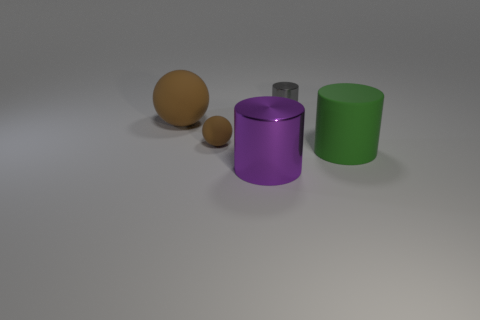Are there more shiny cylinders than small rubber spheres?
Ensure brevity in your answer.  Yes. Do the cylinder that is behind the large rubber cylinder and the cylinder that is to the left of the small gray object have the same size?
Your answer should be compact. No. How many rubber objects are on the right side of the large purple shiny object and left of the small cylinder?
Keep it short and to the point. 0. What color is the other shiny thing that is the same shape as the big purple shiny object?
Provide a succinct answer. Gray. Are there fewer shiny objects than gray objects?
Offer a very short reply. No. There is a gray cylinder; is it the same size as the metal cylinder that is in front of the big brown matte ball?
Your answer should be compact. No. What color is the large object that is in front of the big object that is on the right side of the tiny cylinder?
Your response must be concise. Purple. What number of objects are either objects that are on the right side of the small brown rubber object or metallic things that are in front of the tiny metallic object?
Provide a succinct answer. 3. Do the green rubber cylinder and the purple cylinder have the same size?
Offer a very short reply. Yes. There is a metallic object in front of the large brown ball; is it the same shape as the large thing right of the purple shiny thing?
Ensure brevity in your answer.  Yes. 